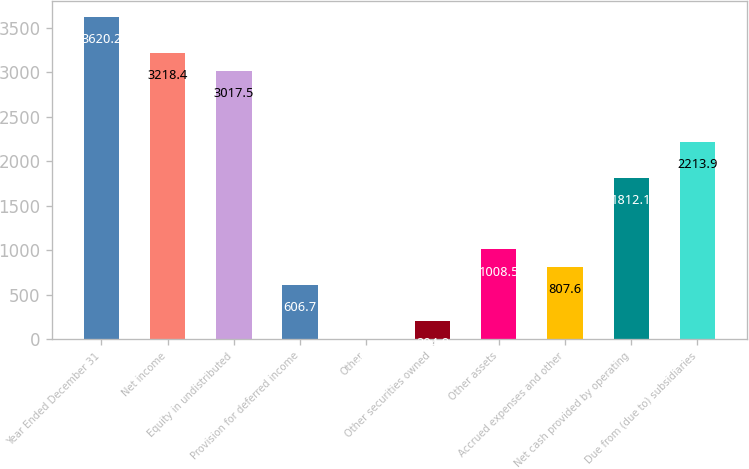Convert chart. <chart><loc_0><loc_0><loc_500><loc_500><bar_chart><fcel>Year Ended December 31<fcel>Net income<fcel>Equity in undistributed<fcel>Provision for deferred income<fcel>Other<fcel>Other securities owned<fcel>Other assets<fcel>Accrued expenses and other<fcel>Net cash provided by operating<fcel>Due from (due to) subsidiaries<nl><fcel>3620.2<fcel>3218.4<fcel>3017.5<fcel>606.7<fcel>4<fcel>204.9<fcel>1008.5<fcel>807.6<fcel>1812.1<fcel>2213.9<nl></chart> 